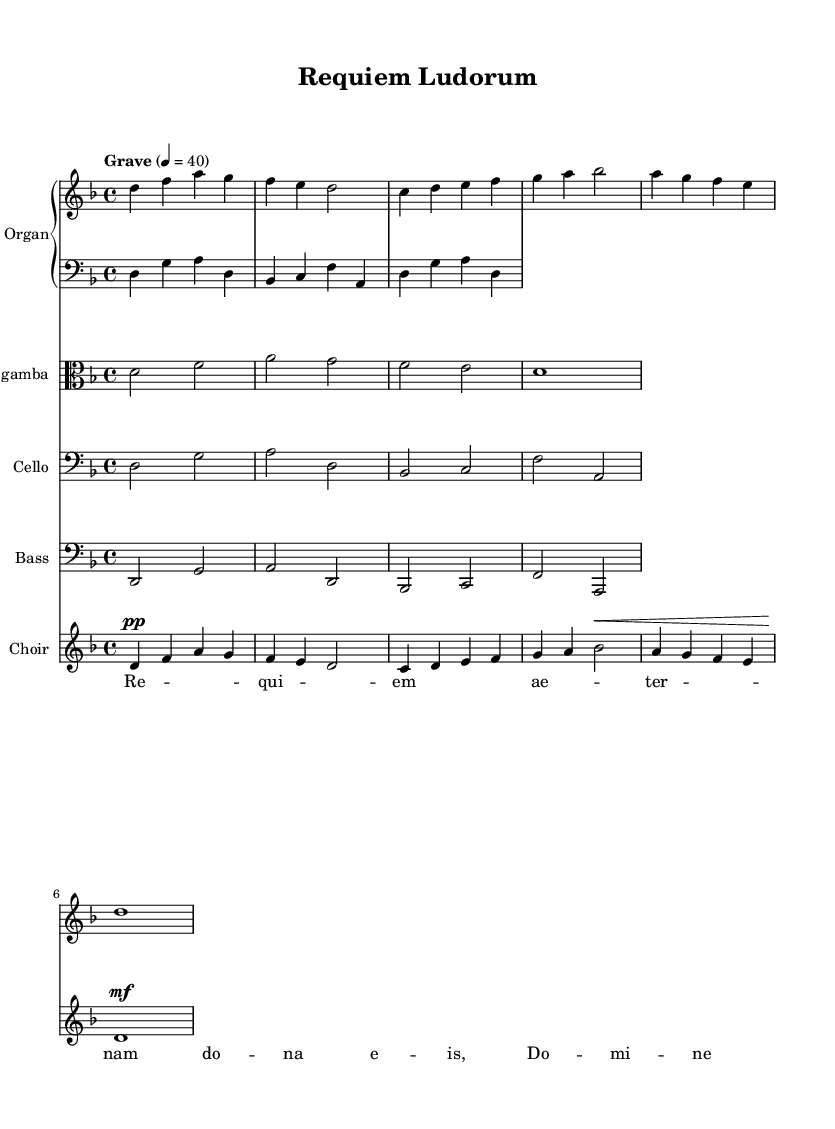What is the key signature of this music? The key signature is indicated at the beginning of the staff. In this case, it shows a B-flat and an E-flat, which signifies that the music is in D minor.
Answer: D minor What is the time signature of this music? The time signature is specified at the beginning of the score, which shows a 4 over 4, indicating four beats in each measure.
Answer: 4/4 What is the indicated tempo for this piece? The tempo marking in the score indicates "Grave," which describes a very slow and solemn pace, marked at 40 beats per minute.
Answer: Grave How many measures are there in the choir's part? By counting the distinct groupings of notes in the choir line, we find there are 5 measures present in the music.
Answer: 5 Which instrument is the highest in pitch? The upper staff represents the Organ, specifically the right hand part, which plays the highest notes compared to the other instruments as indicated by the note placements on the staff.
Answer: Organ What dynamic marking is used for the choir's opening? The dynamic marking at the beginning of the choir part is "pp," which stands for "pianissimo," indicating the music should be played very softly.
Answer: pp What type of music does this piece represent? This piece is identified as "Sacred Music," particularly a requiem, which is a mass for the deceased and often bears dark, solemn themes fitting for a somber atmosphere.
Answer: Sacred Music 